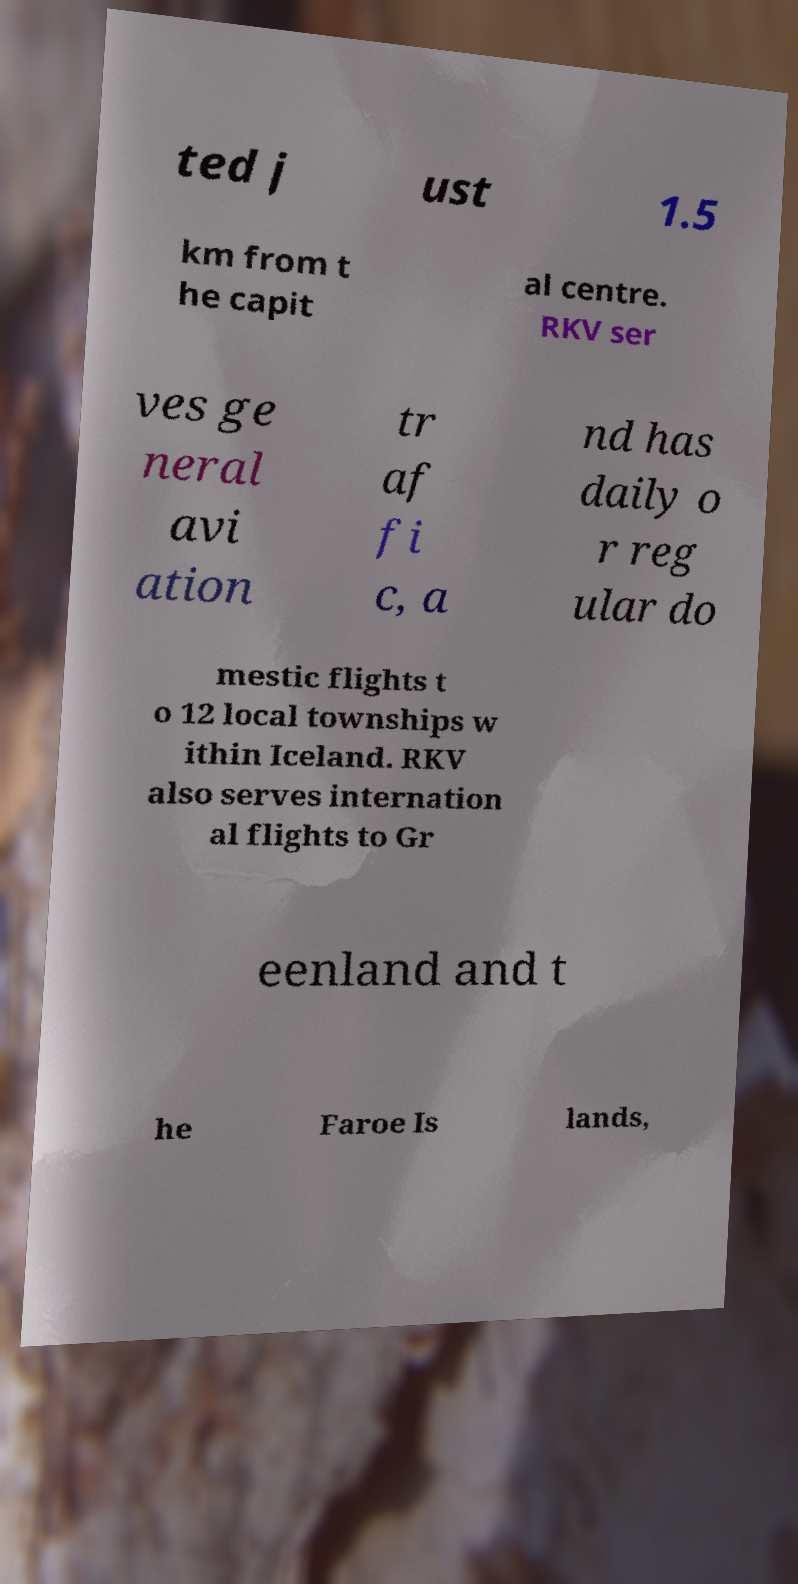Please identify and transcribe the text found in this image. ted j ust 1.5 km from t he capit al centre. RKV ser ves ge neral avi ation tr af fi c, a nd has daily o r reg ular do mestic flights t o 12 local townships w ithin Iceland. RKV also serves internation al flights to Gr eenland and t he Faroe Is lands, 